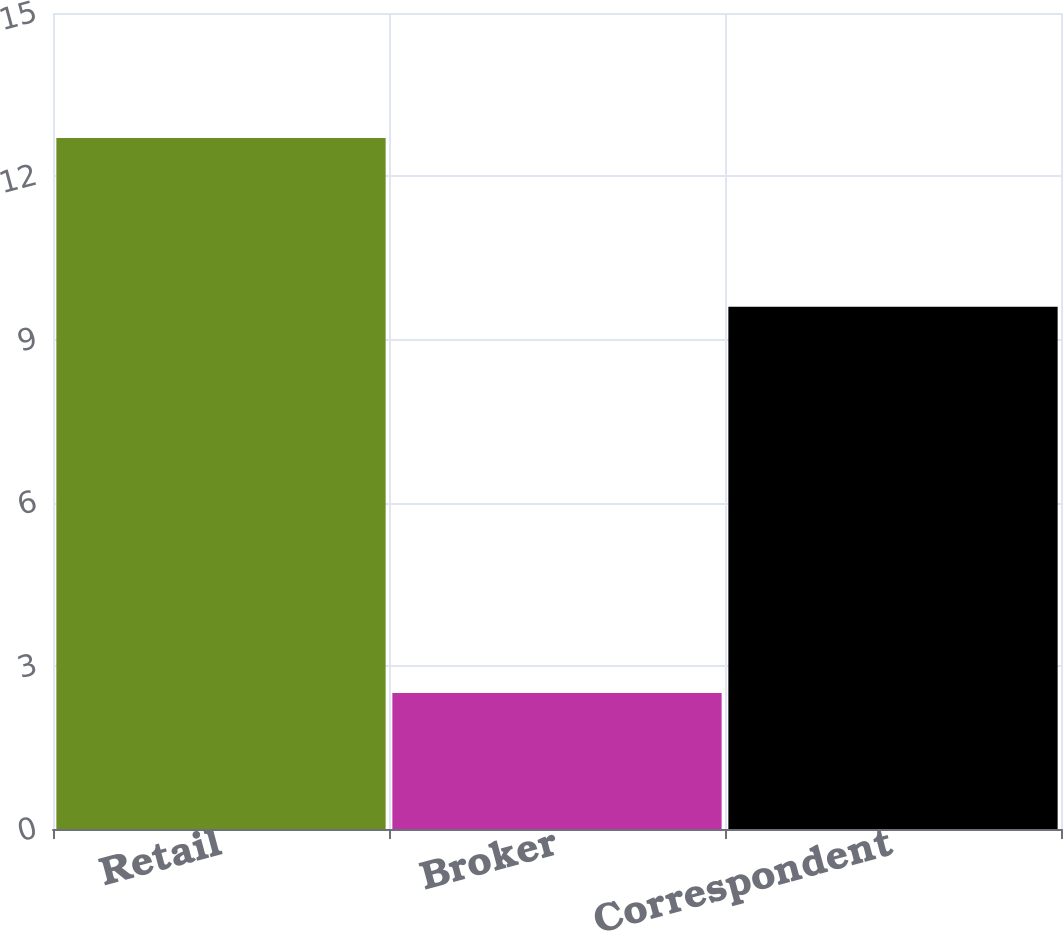Convert chart. <chart><loc_0><loc_0><loc_500><loc_500><bar_chart><fcel>Retail<fcel>Broker<fcel>Correspondent<nl><fcel>12.7<fcel>2.5<fcel>9.6<nl></chart> 